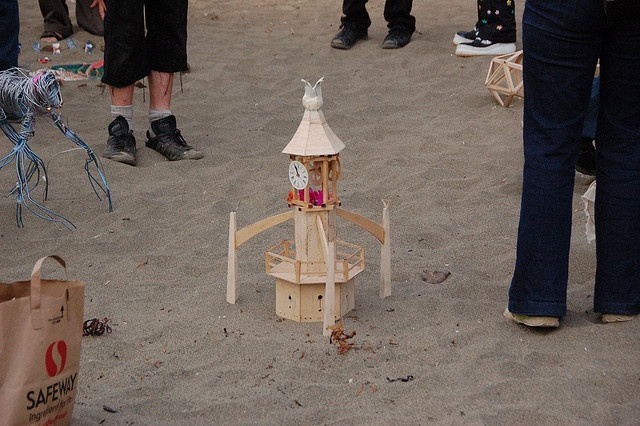Describe the objects in this image and their specific colors. I can see people in black, gray, and navy tones, handbag in black, gray, brown, and maroon tones, people in black, gray, brown, and maroon tones, people in black, darkgray, and gray tones, and people in black and gray tones in this image. 